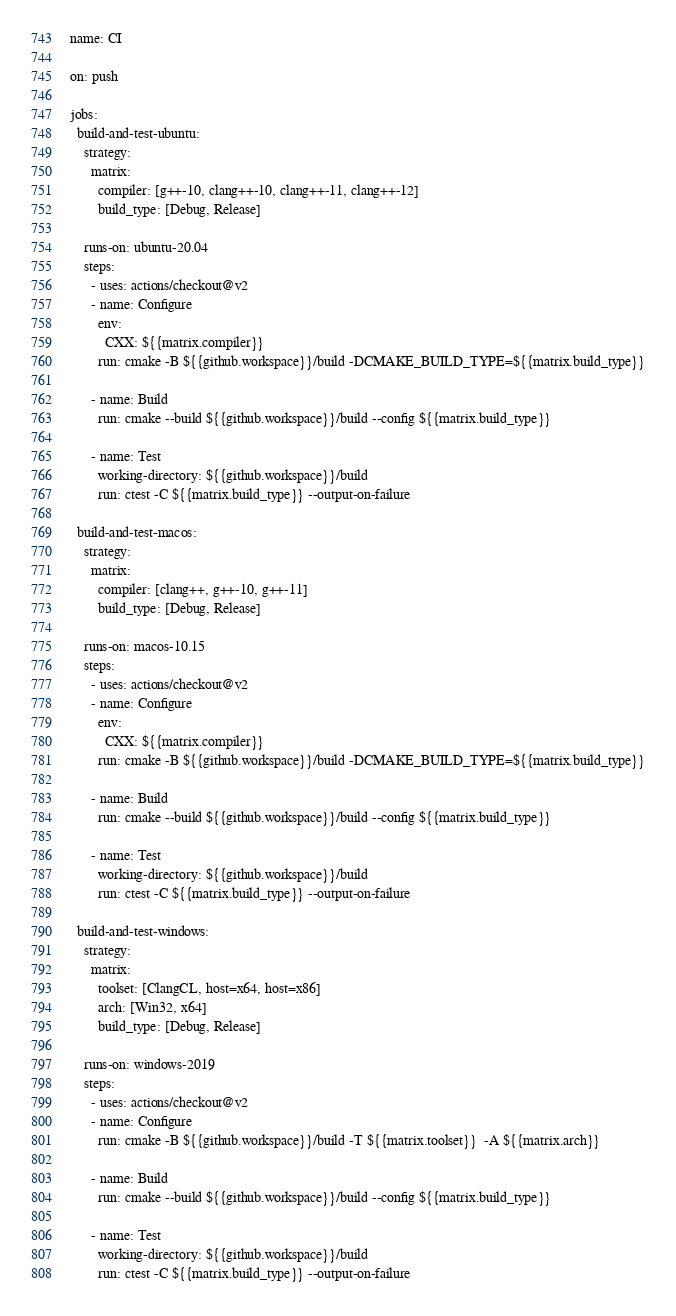<code> <loc_0><loc_0><loc_500><loc_500><_YAML_>name: CI

on: push

jobs:
  build-and-test-ubuntu:
    strategy:
      matrix:
        compiler: [g++-10, clang++-10, clang++-11, clang++-12]
        build_type: [Debug, Release]

    runs-on: ubuntu-20.04 
    steps:
      - uses: actions/checkout@v2
      - name: Configure
        env:
          CXX: ${{matrix.compiler}}
        run: cmake -B ${{github.workspace}}/build -DCMAKE_BUILD_TYPE=${{matrix.build_type}}

      - name: Build
        run: cmake --build ${{github.workspace}}/build --config ${{matrix.build_type}}

      - name: Test
        working-directory: ${{github.workspace}}/build
        run: ctest -C ${{matrix.build_type}} --output-on-failure
  
  build-and-test-macos:
    strategy:
      matrix:
        compiler: [clang++, g++-10, g++-11]
        build_type: [Debug, Release]

    runs-on: macos-10.15
    steps:
      - uses: actions/checkout@v2
      - name: Configure
        env:
          CXX: ${{matrix.compiler}}
        run: cmake -B ${{github.workspace}}/build -DCMAKE_BUILD_TYPE=${{matrix.build_type}}

      - name: Build
        run: cmake --build ${{github.workspace}}/build --config ${{matrix.build_type}}

      - name: Test
        working-directory: ${{github.workspace}}/build
        run: ctest -C ${{matrix.build_type}} --output-on-failure

  build-and-test-windows:
    strategy:
      matrix:
        toolset: [ClangCL, host=x64, host=x86]
        arch: [Win32, x64]
        build_type: [Debug, Release]

    runs-on: windows-2019
    steps:
      - uses: actions/checkout@v2
      - name: Configure
        run: cmake -B ${{github.workspace}}/build -T ${{matrix.toolset}}  -A ${{matrix.arch}}

      - name: Build
        run: cmake --build ${{github.workspace}}/build --config ${{matrix.build_type}}

      - name: Test
        working-directory: ${{github.workspace}}/build
        run: ctest -C ${{matrix.build_type}} --output-on-failure</code> 